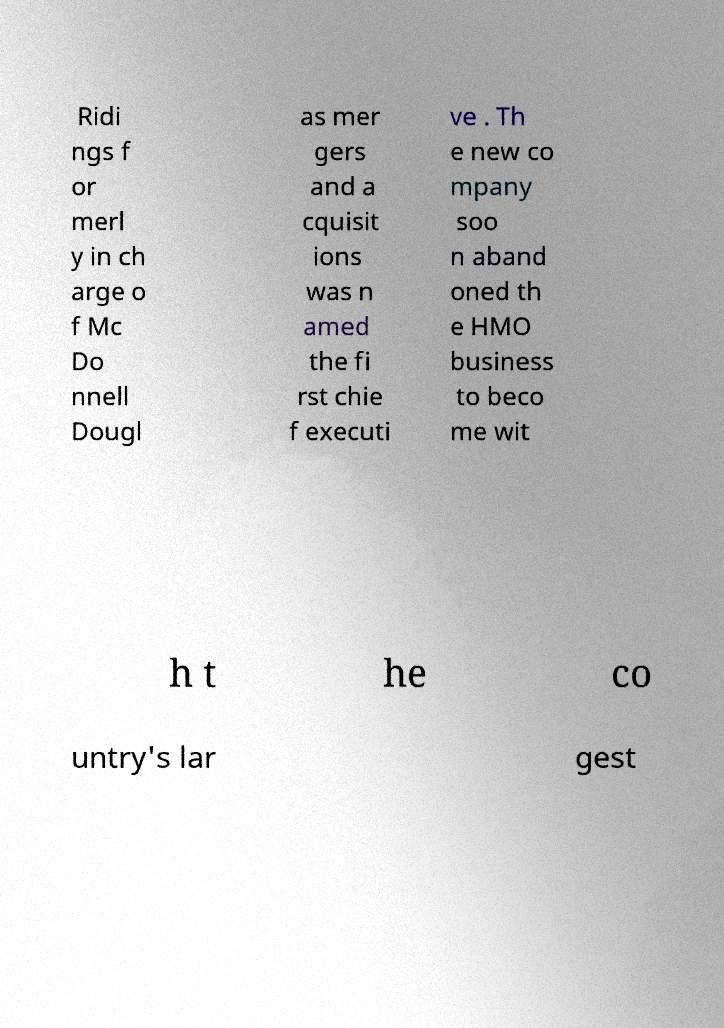There's text embedded in this image that I need extracted. Can you transcribe it verbatim? Ridi ngs f or merl y in ch arge o f Mc Do nnell Dougl as mer gers and a cquisit ions was n amed the fi rst chie f executi ve . Th e new co mpany soo n aband oned th e HMO business to beco me wit h t he co untry's lar gest 